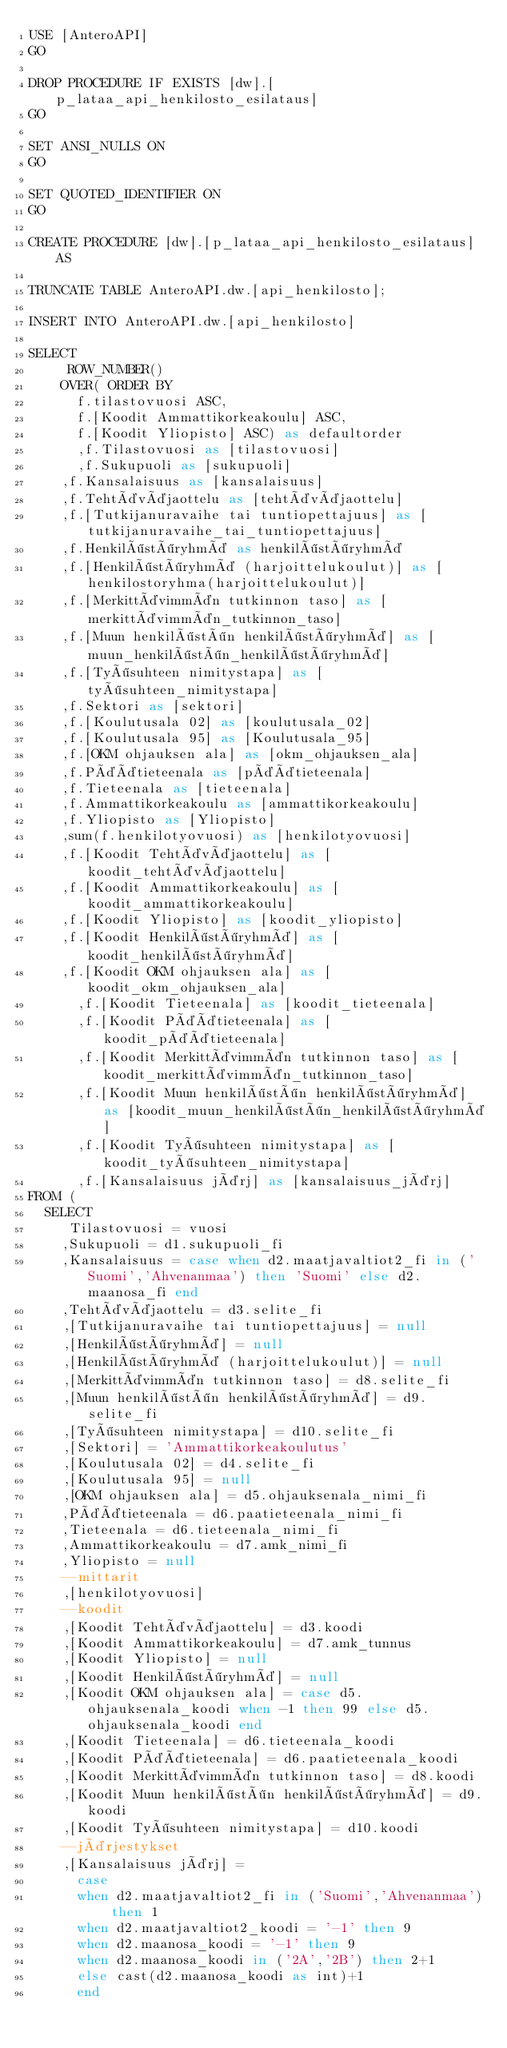Convert code to text. <code><loc_0><loc_0><loc_500><loc_500><_SQL_>USE [AnteroAPI]
GO

DROP PROCEDURE IF EXISTS [dw].[p_lataa_api_henkilosto_esilataus]
GO

SET ANSI_NULLS ON
GO

SET QUOTED_IDENTIFIER ON
GO

CREATE PROCEDURE [dw].[p_lataa_api_henkilosto_esilataus] AS

TRUNCATE TABLE AnteroAPI.dw.[api_henkilosto];

INSERT INTO AnteroAPI.dw.[api_henkilosto]

SELECT 
	   ROW_NUMBER() 
		OVER( ORDER BY 
			f.tilastovuosi ASC, 
			f.[Koodit Ammattikorkeakoulu] ASC, 
			f.[Koodit Yliopisto] ASC) as defaultorder
      ,f.Tilastovuosi as [tilastovuosi]
      ,f.Sukupuoli as [sukupuoli]
	  ,f.Kansalaisuus as [kansalaisuus]
	  ,f.Tehtäväjaottelu as [tehtäväjaottelu]
	  ,f.[Tutkijanuravaihe tai tuntiopettajuus] as [tutkijanuravaihe_tai_tuntiopettajuus]
	  ,f.Henkilöstöryhmä as henkilöstöryhmä
	  ,f.[Henkilöstöryhmä (harjoittelukoulut)] as [henkilostoryhma(harjoittelukoulut)]
	  ,f.[Merkittävimmän tutkinnon taso] as [merkittävimmän_tutkinnon_taso]
	  ,f.[Muun henkilöstön henkilöstöryhmä] as [muun_henkilöstön_henkilöstöryhmä]
	  ,f.[Työsuhteen nimitystapa] as [työsuhteen_nimitystapa]
	  ,f.Sektori as [sektori]
	  ,f.[Koulutusala 02] as [koulutusala_02]
	  ,f.[Koulutusala 95] as [Koulutusala_95]
	  ,f.[OKM ohjauksen ala] as [okm_ohjauksen_ala]
	  ,f.Päätieteenala as [päätieteenala]
	  ,f.Tieteenala as [tieteenala]
	  ,f.Ammattikorkeakoulu as [ammattikorkeakoulu]
	  ,f.Yliopisto as [Yliopisto]
	  ,sum(f.henkilotyovuosi) as [henkilotyovuosi]
	  ,f.[Koodit Tehtäväjaottelu] as [koodit_tehtäväjaottelu]
	  ,f.[Koodit Ammattikorkeakoulu] as [koodit_ammattikorkeakoulu]
	  ,f.[Koodit Yliopisto] as [koodit_yliopisto]
	  ,f.[Koodit Henkilöstöryhmä] as [koodit_henkilöstöryhmä]
	  ,f.[Koodit OKM ohjauksen ala] as [koodit_okm_ohjauksen_ala]
      ,f.[Koodit Tieteenala] as [koodit_tieteenala]
      ,f.[Koodit Päätieteenala] as [koodit_päätieteenala]
      ,f.[Koodit Merkittävimmän tutkinnon taso] as [koodit_merkittävimmän_tutkinnon_taso]
      ,f.[Koodit Muun henkilöstön henkilöstöryhmä] as [koodit_muun_henkilöstön_henkilöstöryhmä]
      ,f.[Koodit Työsuhteen nimitystapa] as [koodit_työsuhteen_nimitystapa]
      ,f.[Kansalaisuus järj] as [kansalaisuus_järj]
FROM (
	SELECT
		 Tilastovuosi = vuosi
		,Sukupuoli = d1.sukupuoli_fi
		,Kansalaisuus = case when d2.maatjavaltiot2_fi in ('Suomi','Ahvenanmaa') then 'Suomi' else d2.maanosa_fi end
		,Tehtäväjaottelu = d3.selite_fi
		,[Tutkijanuravaihe tai tuntiopettajuus] = null
		,[Henkilöstöryhmä] = null
		,[Henkilöstöryhmä (harjoittelukoulut)] = null
		,[Merkittävimmän tutkinnon taso] = d8.selite_fi
		,[Muun henkilöstön henkilöstöryhmä] = d9.selite_fi
		,[Työsuhteen nimitystapa] = d10.selite_fi
		,[Sektori] = 'Ammattikorkeakoulutus'
		,[Koulutusala 02] = d4.selite_fi
		,[Koulutusala 95] = null
		,[OKM ohjauksen ala] = d5.ohjauksenala_nimi_fi
		,Päätieteenala = d6.paatieteenala_nimi_fi
		,Tieteenala = d6.tieteenala_nimi_fi
		,Ammattikorkeakoulu = d7.amk_nimi_fi
		,Yliopisto = null
		--mittarit
		,[henkilotyovuosi]
		--koodit
		,[Koodit Tehtäväjaottelu] = d3.koodi
		,[Koodit Ammattikorkeakoulu] = d7.amk_tunnus
		,[Koodit Yliopisto] = null
		,[Koodit Henkilöstöryhmä] = null
		,[Koodit OKM ohjauksen ala] = case d5.ohjauksenala_koodi when -1 then 99 else d5.ohjauksenala_koodi end
		,[Koodit Tieteenala] = d6.tieteenala_koodi
		,[Koodit Päätieteenala] = d6.paatieteenala_koodi
		,[Koodit Merkittävimmän tutkinnon taso] = d8.koodi
		,[Koodit Muun henkilöstön henkilöstöryhmä] = d9.koodi
		,[Koodit Työsuhteen nimitystapa] = d10.koodi
		--järjestykset
		,[Kansalaisuus järj] =
		  case
		  when d2.maatjavaltiot2_fi in ('Suomi','Ahvenanmaa') then 1
		  when d2.maatjavaltiot2_koodi = '-1' then 9
		  when d2.maanosa_koodi = '-1' then 9
		  when d2.maanosa_koodi in ('2A','2B') then 2+1
		  else cast(d2.maanosa_koodi as int)+1
		  end</code> 